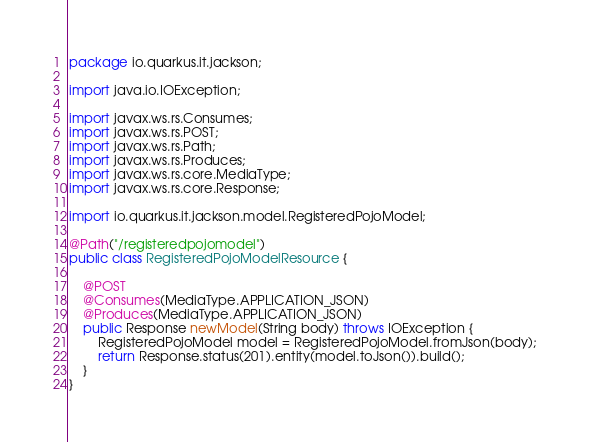Convert code to text. <code><loc_0><loc_0><loc_500><loc_500><_Java_>package io.quarkus.it.jackson;

import java.io.IOException;

import javax.ws.rs.Consumes;
import javax.ws.rs.POST;
import javax.ws.rs.Path;
import javax.ws.rs.Produces;
import javax.ws.rs.core.MediaType;
import javax.ws.rs.core.Response;

import io.quarkus.it.jackson.model.RegisteredPojoModel;

@Path("/registeredpojomodel")
public class RegisteredPojoModelResource {

    @POST
    @Consumes(MediaType.APPLICATION_JSON)
    @Produces(MediaType.APPLICATION_JSON)
    public Response newModel(String body) throws IOException {
        RegisteredPojoModel model = RegisteredPojoModel.fromJson(body);
        return Response.status(201).entity(model.toJson()).build();
    }
}
</code> 